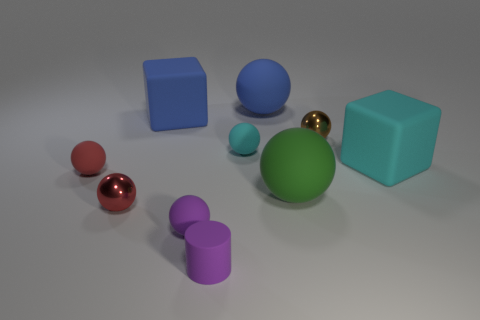Subtract all purple balls. How many balls are left? 6 Subtract all small brown spheres. How many spheres are left? 6 Subtract all green spheres. Subtract all brown cylinders. How many spheres are left? 6 Subtract all blocks. How many objects are left? 8 Add 1 blue balls. How many blue balls exist? 2 Subtract 0 gray blocks. How many objects are left? 10 Subtract all blue things. Subtract all tiny metal blocks. How many objects are left? 8 Add 3 brown balls. How many brown balls are left? 4 